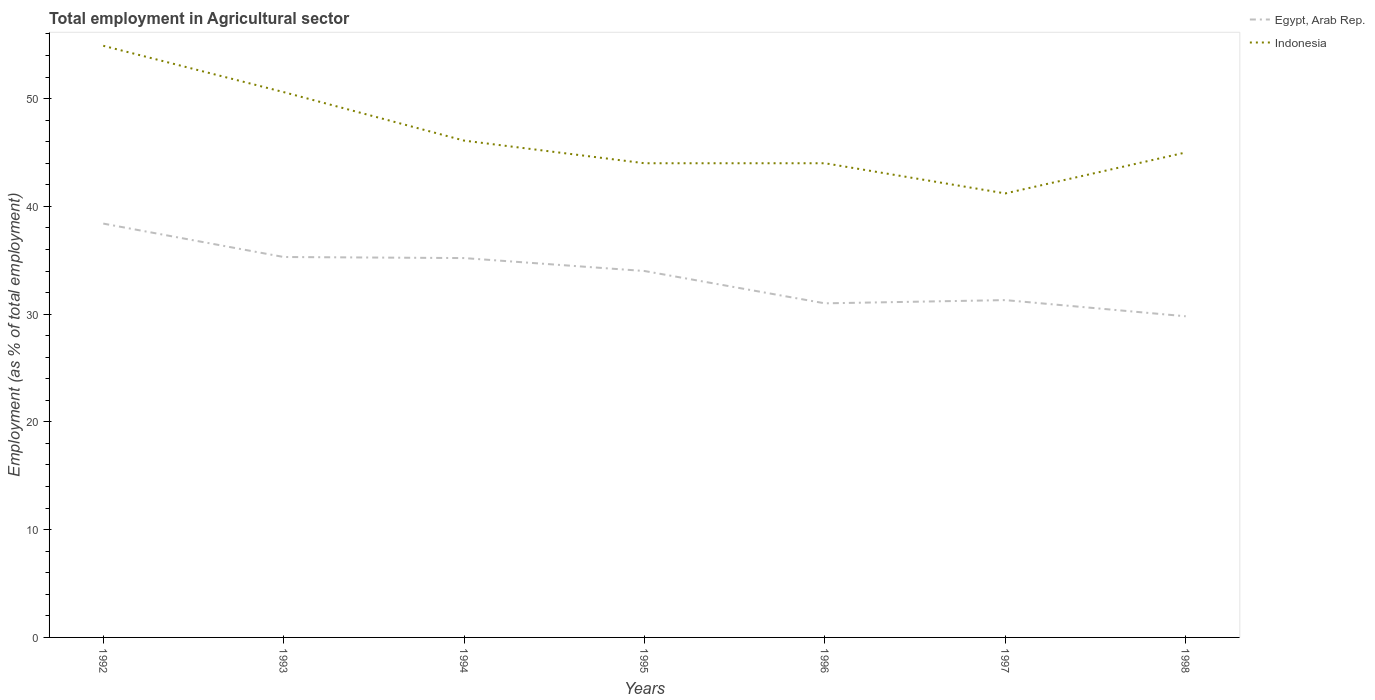How many different coloured lines are there?
Provide a succinct answer. 2. Does the line corresponding to Indonesia intersect with the line corresponding to Egypt, Arab Rep.?
Keep it short and to the point. No. Across all years, what is the maximum employment in agricultural sector in Egypt, Arab Rep.?
Make the answer very short. 29.8. What is the total employment in agricultural sector in Egypt, Arab Rep. in the graph?
Make the answer very short. 7.4. What is the difference between the highest and the second highest employment in agricultural sector in Indonesia?
Make the answer very short. 13.7. What is the difference between two consecutive major ticks on the Y-axis?
Your response must be concise. 10. Does the graph contain any zero values?
Offer a very short reply. No. Where does the legend appear in the graph?
Offer a very short reply. Top right. How many legend labels are there?
Give a very brief answer. 2. What is the title of the graph?
Give a very brief answer. Total employment in Agricultural sector. Does "Brunei Darussalam" appear as one of the legend labels in the graph?
Keep it short and to the point. No. What is the label or title of the X-axis?
Provide a short and direct response. Years. What is the label or title of the Y-axis?
Offer a terse response. Employment (as % of total employment). What is the Employment (as % of total employment) of Egypt, Arab Rep. in 1992?
Give a very brief answer. 38.4. What is the Employment (as % of total employment) in Indonesia in 1992?
Make the answer very short. 54.9. What is the Employment (as % of total employment) of Egypt, Arab Rep. in 1993?
Provide a succinct answer. 35.3. What is the Employment (as % of total employment) of Indonesia in 1993?
Offer a terse response. 50.6. What is the Employment (as % of total employment) of Egypt, Arab Rep. in 1994?
Your response must be concise. 35.2. What is the Employment (as % of total employment) of Indonesia in 1994?
Provide a short and direct response. 46.1. What is the Employment (as % of total employment) of Egypt, Arab Rep. in 1995?
Your answer should be very brief. 34. What is the Employment (as % of total employment) in Indonesia in 1995?
Your answer should be compact. 44. What is the Employment (as % of total employment) of Indonesia in 1996?
Give a very brief answer. 44. What is the Employment (as % of total employment) of Egypt, Arab Rep. in 1997?
Offer a terse response. 31.3. What is the Employment (as % of total employment) in Indonesia in 1997?
Provide a short and direct response. 41.2. What is the Employment (as % of total employment) in Egypt, Arab Rep. in 1998?
Provide a succinct answer. 29.8. What is the Employment (as % of total employment) of Indonesia in 1998?
Keep it short and to the point. 45. Across all years, what is the maximum Employment (as % of total employment) in Egypt, Arab Rep.?
Offer a terse response. 38.4. Across all years, what is the maximum Employment (as % of total employment) in Indonesia?
Offer a terse response. 54.9. Across all years, what is the minimum Employment (as % of total employment) of Egypt, Arab Rep.?
Make the answer very short. 29.8. Across all years, what is the minimum Employment (as % of total employment) in Indonesia?
Make the answer very short. 41.2. What is the total Employment (as % of total employment) of Egypt, Arab Rep. in the graph?
Your response must be concise. 235. What is the total Employment (as % of total employment) in Indonesia in the graph?
Your response must be concise. 325.8. What is the difference between the Employment (as % of total employment) in Indonesia in 1992 and that in 1993?
Provide a succinct answer. 4.3. What is the difference between the Employment (as % of total employment) in Egypt, Arab Rep. in 1992 and that in 1994?
Make the answer very short. 3.2. What is the difference between the Employment (as % of total employment) of Indonesia in 1992 and that in 1996?
Your answer should be very brief. 10.9. What is the difference between the Employment (as % of total employment) in Egypt, Arab Rep. in 1992 and that in 1998?
Keep it short and to the point. 8.6. What is the difference between the Employment (as % of total employment) of Indonesia in 1993 and that in 1994?
Provide a short and direct response. 4.5. What is the difference between the Employment (as % of total employment) of Indonesia in 1993 and that in 1995?
Ensure brevity in your answer.  6.6. What is the difference between the Employment (as % of total employment) in Egypt, Arab Rep. in 1993 and that in 1996?
Provide a succinct answer. 4.3. What is the difference between the Employment (as % of total employment) in Indonesia in 1993 and that in 1996?
Keep it short and to the point. 6.6. What is the difference between the Employment (as % of total employment) of Egypt, Arab Rep. in 1993 and that in 1997?
Make the answer very short. 4. What is the difference between the Employment (as % of total employment) in Indonesia in 1993 and that in 1997?
Provide a short and direct response. 9.4. What is the difference between the Employment (as % of total employment) of Egypt, Arab Rep. in 1993 and that in 1998?
Your answer should be very brief. 5.5. What is the difference between the Employment (as % of total employment) of Egypt, Arab Rep. in 1994 and that in 1995?
Your response must be concise. 1.2. What is the difference between the Employment (as % of total employment) of Indonesia in 1994 and that in 1995?
Offer a terse response. 2.1. What is the difference between the Employment (as % of total employment) of Egypt, Arab Rep. in 1994 and that in 1996?
Offer a terse response. 4.2. What is the difference between the Employment (as % of total employment) in Indonesia in 1995 and that in 1998?
Keep it short and to the point. -1. What is the difference between the Employment (as % of total employment) of Indonesia in 1996 and that in 1998?
Keep it short and to the point. -1. What is the difference between the Employment (as % of total employment) of Egypt, Arab Rep. in 1992 and the Employment (as % of total employment) of Indonesia in 1993?
Provide a short and direct response. -12.2. What is the difference between the Employment (as % of total employment) in Egypt, Arab Rep. in 1992 and the Employment (as % of total employment) in Indonesia in 1995?
Keep it short and to the point. -5.6. What is the difference between the Employment (as % of total employment) of Egypt, Arab Rep. in 1992 and the Employment (as % of total employment) of Indonesia in 1996?
Keep it short and to the point. -5.6. What is the difference between the Employment (as % of total employment) in Egypt, Arab Rep. in 1993 and the Employment (as % of total employment) in Indonesia in 1994?
Offer a terse response. -10.8. What is the difference between the Employment (as % of total employment) of Egypt, Arab Rep. in 1993 and the Employment (as % of total employment) of Indonesia in 1995?
Your answer should be compact. -8.7. What is the difference between the Employment (as % of total employment) of Egypt, Arab Rep. in 1993 and the Employment (as % of total employment) of Indonesia in 1996?
Give a very brief answer. -8.7. What is the difference between the Employment (as % of total employment) in Egypt, Arab Rep. in 1993 and the Employment (as % of total employment) in Indonesia in 1997?
Make the answer very short. -5.9. What is the difference between the Employment (as % of total employment) in Egypt, Arab Rep. in 1994 and the Employment (as % of total employment) in Indonesia in 1996?
Provide a short and direct response. -8.8. What is the difference between the Employment (as % of total employment) in Egypt, Arab Rep. in 1995 and the Employment (as % of total employment) in Indonesia in 1996?
Offer a very short reply. -10. What is the difference between the Employment (as % of total employment) in Egypt, Arab Rep. in 1996 and the Employment (as % of total employment) in Indonesia in 1997?
Offer a terse response. -10.2. What is the difference between the Employment (as % of total employment) in Egypt, Arab Rep. in 1996 and the Employment (as % of total employment) in Indonesia in 1998?
Ensure brevity in your answer.  -14. What is the difference between the Employment (as % of total employment) in Egypt, Arab Rep. in 1997 and the Employment (as % of total employment) in Indonesia in 1998?
Your answer should be compact. -13.7. What is the average Employment (as % of total employment) of Egypt, Arab Rep. per year?
Your answer should be compact. 33.57. What is the average Employment (as % of total employment) in Indonesia per year?
Ensure brevity in your answer.  46.54. In the year 1992, what is the difference between the Employment (as % of total employment) of Egypt, Arab Rep. and Employment (as % of total employment) of Indonesia?
Ensure brevity in your answer.  -16.5. In the year 1993, what is the difference between the Employment (as % of total employment) of Egypt, Arab Rep. and Employment (as % of total employment) of Indonesia?
Your answer should be very brief. -15.3. In the year 1994, what is the difference between the Employment (as % of total employment) in Egypt, Arab Rep. and Employment (as % of total employment) in Indonesia?
Make the answer very short. -10.9. In the year 1997, what is the difference between the Employment (as % of total employment) of Egypt, Arab Rep. and Employment (as % of total employment) of Indonesia?
Keep it short and to the point. -9.9. In the year 1998, what is the difference between the Employment (as % of total employment) in Egypt, Arab Rep. and Employment (as % of total employment) in Indonesia?
Ensure brevity in your answer.  -15.2. What is the ratio of the Employment (as % of total employment) of Egypt, Arab Rep. in 1992 to that in 1993?
Provide a succinct answer. 1.09. What is the ratio of the Employment (as % of total employment) in Indonesia in 1992 to that in 1993?
Provide a short and direct response. 1.08. What is the ratio of the Employment (as % of total employment) in Indonesia in 1992 to that in 1994?
Your answer should be compact. 1.19. What is the ratio of the Employment (as % of total employment) in Egypt, Arab Rep. in 1992 to that in 1995?
Make the answer very short. 1.13. What is the ratio of the Employment (as % of total employment) in Indonesia in 1992 to that in 1995?
Your answer should be compact. 1.25. What is the ratio of the Employment (as % of total employment) of Egypt, Arab Rep. in 1992 to that in 1996?
Keep it short and to the point. 1.24. What is the ratio of the Employment (as % of total employment) of Indonesia in 1992 to that in 1996?
Provide a succinct answer. 1.25. What is the ratio of the Employment (as % of total employment) in Egypt, Arab Rep. in 1992 to that in 1997?
Provide a short and direct response. 1.23. What is the ratio of the Employment (as % of total employment) in Indonesia in 1992 to that in 1997?
Keep it short and to the point. 1.33. What is the ratio of the Employment (as % of total employment) in Egypt, Arab Rep. in 1992 to that in 1998?
Provide a short and direct response. 1.29. What is the ratio of the Employment (as % of total employment) of Indonesia in 1992 to that in 1998?
Your response must be concise. 1.22. What is the ratio of the Employment (as % of total employment) of Indonesia in 1993 to that in 1994?
Your response must be concise. 1.1. What is the ratio of the Employment (as % of total employment) in Egypt, Arab Rep. in 1993 to that in 1995?
Provide a succinct answer. 1.04. What is the ratio of the Employment (as % of total employment) of Indonesia in 1993 to that in 1995?
Your response must be concise. 1.15. What is the ratio of the Employment (as % of total employment) in Egypt, Arab Rep. in 1993 to that in 1996?
Offer a very short reply. 1.14. What is the ratio of the Employment (as % of total employment) in Indonesia in 1993 to that in 1996?
Your answer should be very brief. 1.15. What is the ratio of the Employment (as % of total employment) of Egypt, Arab Rep. in 1993 to that in 1997?
Your answer should be compact. 1.13. What is the ratio of the Employment (as % of total employment) of Indonesia in 1993 to that in 1997?
Ensure brevity in your answer.  1.23. What is the ratio of the Employment (as % of total employment) in Egypt, Arab Rep. in 1993 to that in 1998?
Keep it short and to the point. 1.18. What is the ratio of the Employment (as % of total employment) in Indonesia in 1993 to that in 1998?
Make the answer very short. 1.12. What is the ratio of the Employment (as % of total employment) of Egypt, Arab Rep. in 1994 to that in 1995?
Your answer should be very brief. 1.04. What is the ratio of the Employment (as % of total employment) in Indonesia in 1994 to that in 1995?
Make the answer very short. 1.05. What is the ratio of the Employment (as % of total employment) of Egypt, Arab Rep. in 1994 to that in 1996?
Offer a very short reply. 1.14. What is the ratio of the Employment (as % of total employment) of Indonesia in 1994 to that in 1996?
Keep it short and to the point. 1.05. What is the ratio of the Employment (as % of total employment) in Egypt, Arab Rep. in 1994 to that in 1997?
Your response must be concise. 1.12. What is the ratio of the Employment (as % of total employment) in Indonesia in 1994 to that in 1997?
Your answer should be compact. 1.12. What is the ratio of the Employment (as % of total employment) in Egypt, Arab Rep. in 1994 to that in 1998?
Keep it short and to the point. 1.18. What is the ratio of the Employment (as % of total employment) of Indonesia in 1994 to that in 1998?
Your answer should be compact. 1.02. What is the ratio of the Employment (as % of total employment) in Egypt, Arab Rep. in 1995 to that in 1996?
Give a very brief answer. 1.1. What is the ratio of the Employment (as % of total employment) in Egypt, Arab Rep. in 1995 to that in 1997?
Your answer should be very brief. 1.09. What is the ratio of the Employment (as % of total employment) of Indonesia in 1995 to that in 1997?
Keep it short and to the point. 1.07. What is the ratio of the Employment (as % of total employment) in Egypt, Arab Rep. in 1995 to that in 1998?
Ensure brevity in your answer.  1.14. What is the ratio of the Employment (as % of total employment) in Indonesia in 1995 to that in 1998?
Offer a very short reply. 0.98. What is the ratio of the Employment (as % of total employment) of Egypt, Arab Rep. in 1996 to that in 1997?
Your answer should be very brief. 0.99. What is the ratio of the Employment (as % of total employment) of Indonesia in 1996 to that in 1997?
Provide a short and direct response. 1.07. What is the ratio of the Employment (as % of total employment) of Egypt, Arab Rep. in 1996 to that in 1998?
Ensure brevity in your answer.  1.04. What is the ratio of the Employment (as % of total employment) of Indonesia in 1996 to that in 1998?
Provide a short and direct response. 0.98. What is the ratio of the Employment (as % of total employment) in Egypt, Arab Rep. in 1997 to that in 1998?
Give a very brief answer. 1.05. What is the ratio of the Employment (as % of total employment) of Indonesia in 1997 to that in 1998?
Your response must be concise. 0.92. What is the difference between the highest and the second highest Employment (as % of total employment) of Egypt, Arab Rep.?
Provide a short and direct response. 3.1. 